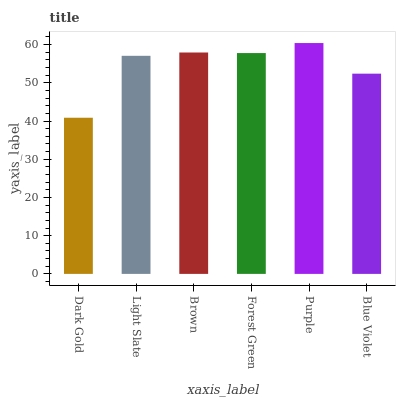Is Dark Gold the minimum?
Answer yes or no. Yes. Is Purple the maximum?
Answer yes or no. Yes. Is Light Slate the minimum?
Answer yes or no. No. Is Light Slate the maximum?
Answer yes or no. No. Is Light Slate greater than Dark Gold?
Answer yes or no. Yes. Is Dark Gold less than Light Slate?
Answer yes or no. Yes. Is Dark Gold greater than Light Slate?
Answer yes or no. No. Is Light Slate less than Dark Gold?
Answer yes or no. No. Is Forest Green the high median?
Answer yes or no. Yes. Is Light Slate the low median?
Answer yes or no. Yes. Is Purple the high median?
Answer yes or no. No. Is Brown the low median?
Answer yes or no. No. 